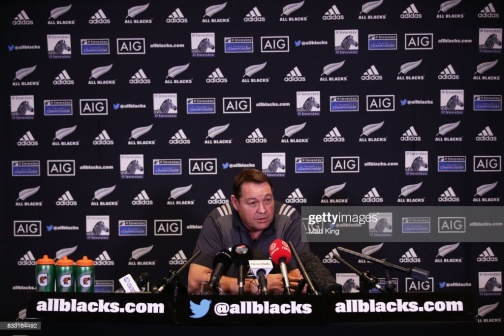What do you think is going on in this snapshot? The image showcases a press conference where a man, centrally positioned at a desk, appears to be addressing the media. Dressed in a blue shirt, he is engaged in conversation through a microphone. The desk is covered with various items, including water bottles, suggesting an extended session. A wall behind him is filled with logos, predominantly from 'allblacks.com' and 'AIG', indicating a setting related to the All Blacks rugby team, possibly a post-match or pre-match press event. The balanced composition captures the organized chaos typical of media events, with each element adding to the narrative of sports and public communication. 